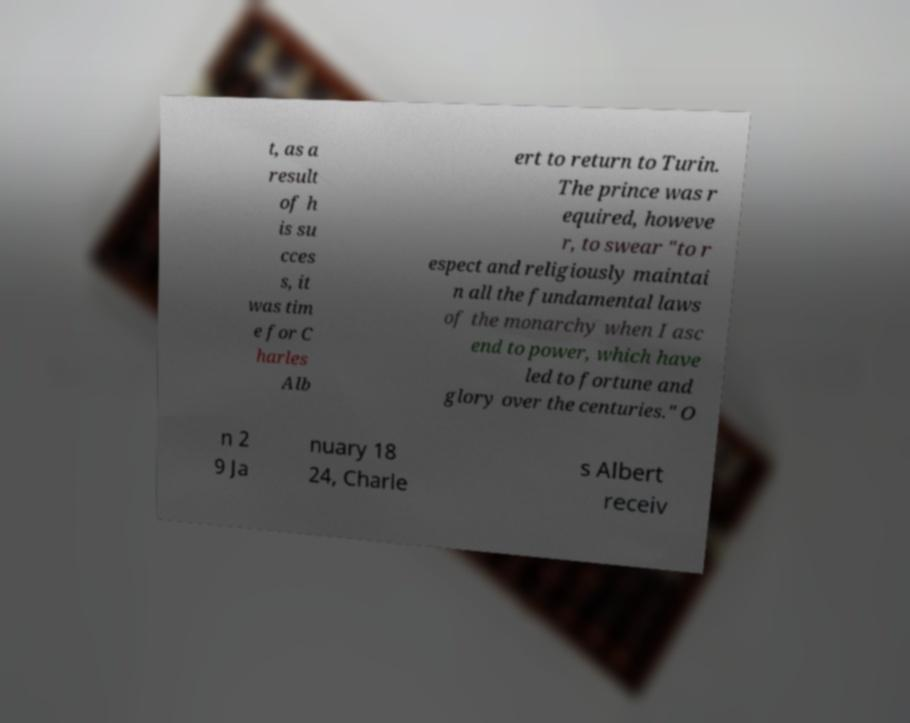Can you accurately transcribe the text from the provided image for me? t, as a result of h is su cces s, it was tim e for C harles Alb ert to return to Turin. The prince was r equired, howeve r, to swear "to r espect and religiously maintai n all the fundamental laws of the monarchy when I asc end to power, which have led to fortune and glory over the centuries." O n 2 9 Ja nuary 18 24, Charle s Albert receiv 